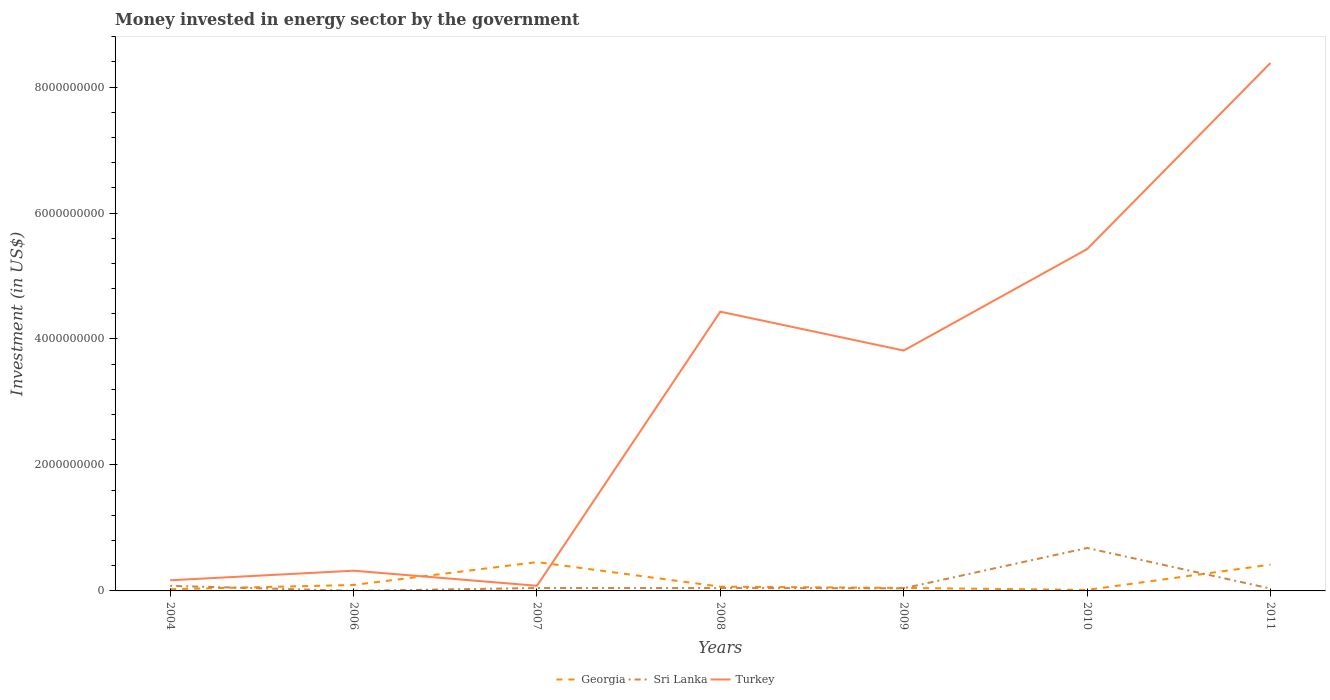Does the line corresponding to Sri Lanka intersect with the line corresponding to Turkey?
Offer a terse response. No. In which year was the money spent in energy sector in Sri Lanka maximum?
Ensure brevity in your answer.  2006. What is the total money spent in energy sector in Turkey in the graph?
Provide a succinct answer. -8.06e+09. What is the difference between the highest and the second highest money spent in energy sector in Turkey?
Offer a very short reply. 8.30e+09. What is the difference between the highest and the lowest money spent in energy sector in Turkey?
Your answer should be compact. 4. Is the money spent in energy sector in Turkey strictly greater than the money spent in energy sector in Sri Lanka over the years?
Your answer should be compact. No. How many lines are there?
Your answer should be very brief. 3. Does the graph contain any zero values?
Your response must be concise. No. Where does the legend appear in the graph?
Keep it short and to the point. Bottom center. How are the legend labels stacked?
Provide a short and direct response. Horizontal. What is the title of the graph?
Offer a very short reply. Money invested in energy sector by the government. What is the label or title of the X-axis?
Make the answer very short. Years. What is the label or title of the Y-axis?
Offer a very short reply. Investment (in US$). What is the Investment (in US$) of Georgia in 2004?
Offer a terse response. 2.70e+07. What is the Investment (in US$) in Sri Lanka in 2004?
Your response must be concise. 8.08e+07. What is the Investment (in US$) of Turkey in 2004?
Your answer should be compact. 1.69e+08. What is the Investment (in US$) of Georgia in 2006?
Ensure brevity in your answer.  9.45e+07. What is the Investment (in US$) of Turkey in 2006?
Offer a terse response. 3.21e+08. What is the Investment (in US$) of Georgia in 2007?
Offer a very short reply. 4.58e+08. What is the Investment (in US$) in Sri Lanka in 2007?
Your answer should be very brief. 4.60e+07. What is the Investment (in US$) of Turkey in 2007?
Offer a very short reply. 8.16e+07. What is the Investment (in US$) in Georgia in 2008?
Make the answer very short. 6.78e+07. What is the Investment (in US$) in Sri Lanka in 2008?
Provide a succinct answer. 4.56e+07. What is the Investment (in US$) in Turkey in 2008?
Provide a succinct answer. 4.43e+09. What is the Investment (in US$) of Georgia in 2009?
Ensure brevity in your answer.  4.77e+07. What is the Investment (in US$) in Sri Lanka in 2009?
Ensure brevity in your answer.  4.17e+07. What is the Investment (in US$) in Turkey in 2009?
Offer a terse response. 3.82e+09. What is the Investment (in US$) in Georgia in 2010?
Give a very brief answer. 1.57e+07. What is the Investment (in US$) of Sri Lanka in 2010?
Ensure brevity in your answer.  6.82e+08. What is the Investment (in US$) in Turkey in 2010?
Offer a terse response. 5.43e+09. What is the Investment (in US$) in Georgia in 2011?
Provide a short and direct response. 4.17e+08. What is the Investment (in US$) of Sri Lanka in 2011?
Offer a terse response. 3.74e+07. What is the Investment (in US$) of Turkey in 2011?
Offer a very short reply. 8.38e+09. Across all years, what is the maximum Investment (in US$) in Georgia?
Provide a short and direct response. 4.58e+08. Across all years, what is the maximum Investment (in US$) of Sri Lanka?
Make the answer very short. 6.82e+08. Across all years, what is the maximum Investment (in US$) in Turkey?
Give a very brief answer. 8.38e+09. Across all years, what is the minimum Investment (in US$) of Georgia?
Give a very brief answer. 1.57e+07. Across all years, what is the minimum Investment (in US$) of Sri Lanka?
Your response must be concise. 1.00e+06. Across all years, what is the minimum Investment (in US$) of Turkey?
Provide a short and direct response. 8.16e+07. What is the total Investment (in US$) of Georgia in the graph?
Your answer should be compact. 1.13e+09. What is the total Investment (in US$) of Sri Lanka in the graph?
Your response must be concise. 9.34e+08. What is the total Investment (in US$) in Turkey in the graph?
Provide a succinct answer. 2.26e+1. What is the difference between the Investment (in US$) of Georgia in 2004 and that in 2006?
Keep it short and to the point. -6.75e+07. What is the difference between the Investment (in US$) in Sri Lanka in 2004 and that in 2006?
Offer a very short reply. 7.98e+07. What is the difference between the Investment (in US$) of Turkey in 2004 and that in 2006?
Ensure brevity in your answer.  -1.52e+08. What is the difference between the Investment (in US$) of Georgia in 2004 and that in 2007?
Ensure brevity in your answer.  -4.31e+08. What is the difference between the Investment (in US$) of Sri Lanka in 2004 and that in 2007?
Provide a succinct answer. 3.48e+07. What is the difference between the Investment (in US$) of Turkey in 2004 and that in 2007?
Provide a short and direct response. 8.74e+07. What is the difference between the Investment (in US$) in Georgia in 2004 and that in 2008?
Your answer should be compact. -4.08e+07. What is the difference between the Investment (in US$) in Sri Lanka in 2004 and that in 2008?
Your answer should be compact. 3.52e+07. What is the difference between the Investment (in US$) in Turkey in 2004 and that in 2008?
Provide a short and direct response. -4.26e+09. What is the difference between the Investment (in US$) in Georgia in 2004 and that in 2009?
Provide a succinct answer. -2.07e+07. What is the difference between the Investment (in US$) in Sri Lanka in 2004 and that in 2009?
Make the answer very short. 3.91e+07. What is the difference between the Investment (in US$) in Turkey in 2004 and that in 2009?
Make the answer very short. -3.65e+09. What is the difference between the Investment (in US$) of Georgia in 2004 and that in 2010?
Offer a terse response. 1.13e+07. What is the difference between the Investment (in US$) of Sri Lanka in 2004 and that in 2010?
Give a very brief answer. -6.01e+08. What is the difference between the Investment (in US$) of Turkey in 2004 and that in 2010?
Offer a terse response. -5.26e+09. What is the difference between the Investment (in US$) in Georgia in 2004 and that in 2011?
Your answer should be very brief. -3.90e+08. What is the difference between the Investment (in US$) in Sri Lanka in 2004 and that in 2011?
Make the answer very short. 4.34e+07. What is the difference between the Investment (in US$) of Turkey in 2004 and that in 2011?
Your answer should be compact. -8.21e+09. What is the difference between the Investment (in US$) in Georgia in 2006 and that in 2007?
Your answer should be compact. -3.63e+08. What is the difference between the Investment (in US$) in Sri Lanka in 2006 and that in 2007?
Provide a succinct answer. -4.50e+07. What is the difference between the Investment (in US$) in Turkey in 2006 and that in 2007?
Your answer should be compact. 2.39e+08. What is the difference between the Investment (in US$) in Georgia in 2006 and that in 2008?
Provide a short and direct response. 2.67e+07. What is the difference between the Investment (in US$) in Sri Lanka in 2006 and that in 2008?
Provide a succinct answer. -4.46e+07. What is the difference between the Investment (in US$) of Turkey in 2006 and that in 2008?
Offer a terse response. -4.11e+09. What is the difference between the Investment (in US$) of Georgia in 2006 and that in 2009?
Give a very brief answer. 4.68e+07. What is the difference between the Investment (in US$) of Sri Lanka in 2006 and that in 2009?
Provide a succinct answer. -4.07e+07. What is the difference between the Investment (in US$) of Turkey in 2006 and that in 2009?
Ensure brevity in your answer.  -3.50e+09. What is the difference between the Investment (in US$) of Georgia in 2006 and that in 2010?
Offer a terse response. 7.88e+07. What is the difference between the Investment (in US$) of Sri Lanka in 2006 and that in 2010?
Ensure brevity in your answer.  -6.81e+08. What is the difference between the Investment (in US$) in Turkey in 2006 and that in 2010?
Your response must be concise. -5.11e+09. What is the difference between the Investment (in US$) in Georgia in 2006 and that in 2011?
Keep it short and to the point. -3.22e+08. What is the difference between the Investment (in US$) of Sri Lanka in 2006 and that in 2011?
Provide a succinct answer. -3.64e+07. What is the difference between the Investment (in US$) in Turkey in 2006 and that in 2011?
Keep it short and to the point. -8.06e+09. What is the difference between the Investment (in US$) in Georgia in 2007 and that in 2008?
Make the answer very short. 3.90e+08. What is the difference between the Investment (in US$) of Turkey in 2007 and that in 2008?
Provide a short and direct response. -4.35e+09. What is the difference between the Investment (in US$) in Georgia in 2007 and that in 2009?
Give a very brief answer. 4.10e+08. What is the difference between the Investment (in US$) of Sri Lanka in 2007 and that in 2009?
Give a very brief answer. 4.30e+06. What is the difference between the Investment (in US$) in Turkey in 2007 and that in 2009?
Give a very brief answer. -3.73e+09. What is the difference between the Investment (in US$) in Georgia in 2007 and that in 2010?
Provide a succinct answer. 4.42e+08. What is the difference between the Investment (in US$) in Sri Lanka in 2007 and that in 2010?
Provide a short and direct response. -6.36e+08. What is the difference between the Investment (in US$) in Turkey in 2007 and that in 2010?
Make the answer very short. -5.35e+09. What is the difference between the Investment (in US$) in Georgia in 2007 and that in 2011?
Offer a terse response. 4.07e+07. What is the difference between the Investment (in US$) in Sri Lanka in 2007 and that in 2011?
Your answer should be compact. 8.60e+06. What is the difference between the Investment (in US$) of Turkey in 2007 and that in 2011?
Offer a very short reply. -8.30e+09. What is the difference between the Investment (in US$) in Georgia in 2008 and that in 2009?
Your answer should be very brief. 2.01e+07. What is the difference between the Investment (in US$) of Sri Lanka in 2008 and that in 2009?
Your answer should be very brief. 3.95e+06. What is the difference between the Investment (in US$) in Turkey in 2008 and that in 2009?
Your response must be concise. 6.18e+08. What is the difference between the Investment (in US$) of Georgia in 2008 and that in 2010?
Your response must be concise. 5.21e+07. What is the difference between the Investment (in US$) in Sri Lanka in 2008 and that in 2010?
Your answer should be compact. -6.36e+08. What is the difference between the Investment (in US$) of Turkey in 2008 and that in 2010?
Offer a terse response. -9.93e+08. What is the difference between the Investment (in US$) of Georgia in 2008 and that in 2011?
Give a very brief answer. -3.49e+08. What is the difference between the Investment (in US$) of Sri Lanka in 2008 and that in 2011?
Your response must be concise. 8.25e+06. What is the difference between the Investment (in US$) of Turkey in 2008 and that in 2011?
Give a very brief answer. -3.95e+09. What is the difference between the Investment (in US$) in Georgia in 2009 and that in 2010?
Offer a terse response. 3.20e+07. What is the difference between the Investment (in US$) of Sri Lanka in 2009 and that in 2010?
Offer a terse response. -6.40e+08. What is the difference between the Investment (in US$) in Turkey in 2009 and that in 2010?
Give a very brief answer. -1.61e+09. What is the difference between the Investment (in US$) of Georgia in 2009 and that in 2011?
Your answer should be very brief. -3.69e+08. What is the difference between the Investment (in US$) in Sri Lanka in 2009 and that in 2011?
Your response must be concise. 4.30e+06. What is the difference between the Investment (in US$) in Turkey in 2009 and that in 2011?
Your answer should be very brief. -4.57e+09. What is the difference between the Investment (in US$) in Georgia in 2010 and that in 2011?
Give a very brief answer. -4.01e+08. What is the difference between the Investment (in US$) of Sri Lanka in 2010 and that in 2011?
Your response must be concise. 6.44e+08. What is the difference between the Investment (in US$) in Turkey in 2010 and that in 2011?
Offer a terse response. -2.96e+09. What is the difference between the Investment (in US$) of Georgia in 2004 and the Investment (in US$) of Sri Lanka in 2006?
Your answer should be very brief. 2.60e+07. What is the difference between the Investment (in US$) of Georgia in 2004 and the Investment (in US$) of Turkey in 2006?
Ensure brevity in your answer.  -2.94e+08. What is the difference between the Investment (in US$) in Sri Lanka in 2004 and the Investment (in US$) in Turkey in 2006?
Provide a short and direct response. -2.40e+08. What is the difference between the Investment (in US$) in Georgia in 2004 and the Investment (in US$) in Sri Lanka in 2007?
Your answer should be very brief. -1.90e+07. What is the difference between the Investment (in US$) of Georgia in 2004 and the Investment (in US$) of Turkey in 2007?
Ensure brevity in your answer.  -5.46e+07. What is the difference between the Investment (in US$) in Sri Lanka in 2004 and the Investment (in US$) in Turkey in 2007?
Ensure brevity in your answer.  -8.00e+05. What is the difference between the Investment (in US$) of Georgia in 2004 and the Investment (in US$) of Sri Lanka in 2008?
Offer a very short reply. -1.86e+07. What is the difference between the Investment (in US$) in Georgia in 2004 and the Investment (in US$) in Turkey in 2008?
Offer a terse response. -4.41e+09. What is the difference between the Investment (in US$) of Sri Lanka in 2004 and the Investment (in US$) of Turkey in 2008?
Offer a terse response. -4.35e+09. What is the difference between the Investment (in US$) in Georgia in 2004 and the Investment (in US$) in Sri Lanka in 2009?
Keep it short and to the point. -1.47e+07. What is the difference between the Investment (in US$) in Georgia in 2004 and the Investment (in US$) in Turkey in 2009?
Provide a succinct answer. -3.79e+09. What is the difference between the Investment (in US$) of Sri Lanka in 2004 and the Investment (in US$) of Turkey in 2009?
Keep it short and to the point. -3.74e+09. What is the difference between the Investment (in US$) of Georgia in 2004 and the Investment (in US$) of Sri Lanka in 2010?
Provide a succinct answer. -6.55e+08. What is the difference between the Investment (in US$) of Georgia in 2004 and the Investment (in US$) of Turkey in 2010?
Make the answer very short. -5.40e+09. What is the difference between the Investment (in US$) of Sri Lanka in 2004 and the Investment (in US$) of Turkey in 2010?
Your answer should be compact. -5.35e+09. What is the difference between the Investment (in US$) in Georgia in 2004 and the Investment (in US$) in Sri Lanka in 2011?
Offer a very short reply. -1.04e+07. What is the difference between the Investment (in US$) in Georgia in 2004 and the Investment (in US$) in Turkey in 2011?
Provide a succinct answer. -8.36e+09. What is the difference between the Investment (in US$) in Sri Lanka in 2004 and the Investment (in US$) in Turkey in 2011?
Provide a succinct answer. -8.30e+09. What is the difference between the Investment (in US$) of Georgia in 2006 and the Investment (in US$) of Sri Lanka in 2007?
Keep it short and to the point. 4.85e+07. What is the difference between the Investment (in US$) in Georgia in 2006 and the Investment (in US$) in Turkey in 2007?
Provide a short and direct response. 1.29e+07. What is the difference between the Investment (in US$) in Sri Lanka in 2006 and the Investment (in US$) in Turkey in 2007?
Your answer should be compact. -8.06e+07. What is the difference between the Investment (in US$) of Georgia in 2006 and the Investment (in US$) of Sri Lanka in 2008?
Ensure brevity in your answer.  4.88e+07. What is the difference between the Investment (in US$) in Georgia in 2006 and the Investment (in US$) in Turkey in 2008?
Give a very brief answer. -4.34e+09. What is the difference between the Investment (in US$) of Sri Lanka in 2006 and the Investment (in US$) of Turkey in 2008?
Your answer should be compact. -4.43e+09. What is the difference between the Investment (in US$) of Georgia in 2006 and the Investment (in US$) of Sri Lanka in 2009?
Offer a very short reply. 5.28e+07. What is the difference between the Investment (in US$) of Georgia in 2006 and the Investment (in US$) of Turkey in 2009?
Provide a succinct answer. -3.72e+09. What is the difference between the Investment (in US$) of Sri Lanka in 2006 and the Investment (in US$) of Turkey in 2009?
Provide a succinct answer. -3.82e+09. What is the difference between the Investment (in US$) of Georgia in 2006 and the Investment (in US$) of Sri Lanka in 2010?
Your response must be concise. -5.87e+08. What is the difference between the Investment (in US$) of Georgia in 2006 and the Investment (in US$) of Turkey in 2010?
Provide a short and direct response. -5.33e+09. What is the difference between the Investment (in US$) in Sri Lanka in 2006 and the Investment (in US$) in Turkey in 2010?
Your answer should be compact. -5.43e+09. What is the difference between the Investment (in US$) of Georgia in 2006 and the Investment (in US$) of Sri Lanka in 2011?
Keep it short and to the point. 5.71e+07. What is the difference between the Investment (in US$) in Georgia in 2006 and the Investment (in US$) in Turkey in 2011?
Ensure brevity in your answer.  -8.29e+09. What is the difference between the Investment (in US$) in Sri Lanka in 2006 and the Investment (in US$) in Turkey in 2011?
Keep it short and to the point. -8.38e+09. What is the difference between the Investment (in US$) of Georgia in 2007 and the Investment (in US$) of Sri Lanka in 2008?
Provide a succinct answer. 4.12e+08. What is the difference between the Investment (in US$) of Georgia in 2007 and the Investment (in US$) of Turkey in 2008?
Make the answer very short. -3.98e+09. What is the difference between the Investment (in US$) of Sri Lanka in 2007 and the Investment (in US$) of Turkey in 2008?
Offer a very short reply. -4.39e+09. What is the difference between the Investment (in US$) of Georgia in 2007 and the Investment (in US$) of Sri Lanka in 2009?
Your answer should be compact. 4.16e+08. What is the difference between the Investment (in US$) in Georgia in 2007 and the Investment (in US$) in Turkey in 2009?
Provide a succinct answer. -3.36e+09. What is the difference between the Investment (in US$) in Sri Lanka in 2007 and the Investment (in US$) in Turkey in 2009?
Your answer should be compact. -3.77e+09. What is the difference between the Investment (in US$) in Georgia in 2007 and the Investment (in US$) in Sri Lanka in 2010?
Make the answer very short. -2.24e+08. What is the difference between the Investment (in US$) in Georgia in 2007 and the Investment (in US$) in Turkey in 2010?
Provide a short and direct response. -4.97e+09. What is the difference between the Investment (in US$) of Sri Lanka in 2007 and the Investment (in US$) of Turkey in 2010?
Ensure brevity in your answer.  -5.38e+09. What is the difference between the Investment (in US$) of Georgia in 2007 and the Investment (in US$) of Sri Lanka in 2011?
Give a very brief answer. 4.20e+08. What is the difference between the Investment (in US$) in Georgia in 2007 and the Investment (in US$) in Turkey in 2011?
Give a very brief answer. -7.92e+09. What is the difference between the Investment (in US$) of Sri Lanka in 2007 and the Investment (in US$) of Turkey in 2011?
Your response must be concise. -8.34e+09. What is the difference between the Investment (in US$) of Georgia in 2008 and the Investment (in US$) of Sri Lanka in 2009?
Offer a terse response. 2.61e+07. What is the difference between the Investment (in US$) of Georgia in 2008 and the Investment (in US$) of Turkey in 2009?
Offer a very short reply. -3.75e+09. What is the difference between the Investment (in US$) in Sri Lanka in 2008 and the Investment (in US$) in Turkey in 2009?
Make the answer very short. -3.77e+09. What is the difference between the Investment (in US$) in Georgia in 2008 and the Investment (in US$) in Sri Lanka in 2010?
Your answer should be very brief. -6.14e+08. What is the difference between the Investment (in US$) of Georgia in 2008 and the Investment (in US$) of Turkey in 2010?
Offer a very short reply. -5.36e+09. What is the difference between the Investment (in US$) of Sri Lanka in 2008 and the Investment (in US$) of Turkey in 2010?
Your answer should be compact. -5.38e+09. What is the difference between the Investment (in US$) of Georgia in 2008 and the Investment (in US$) of Sri Lanka in 2011?
Your answer should be very brief. 3.04e+07. What is the difference between the Investment (in US$) of Georgia in 2008 and the Investment (in US$) of Turkey in 2011?
Your response must be concise. -8.31e+09. What is the difference between the Investment (in US$) of Sri Lanka in 2008 and the Investment (in US$) of Turkey in 2011?
Your answer should be very brief. -8.34e+09. What is the difference between the Investment (in US$) in Georgia in 2009 and the Investment (in US$) in Sri Lanka in 2010?
Provide a succinct answer. -6.34e+08. What is the difference between the Investment (in US$) of Georgia in 2009 and the Investment (in US$) of Turkey in 2010?
Provide a short and direct response. -5.38e+09. What is the difference between the Investment (in US$) of Sri Lanka in 2009 and the Investment (in US$) of Turkey in 2010?
Provide a succinct answer. -5.39e+09. What is the difference between the Investment (in US$) in Georgia in 2009 and the Investment (in US$) in Sri Lanka in 2011?
Offer a terse response. 1.03e+07. What is the difference between the Investment (in US$) in Georgia in 2009 and the Investment (in US$) in Turkey in 2011?
Provide a succinct answer. -8.33e+09. What is the difference between the Investment (in US$) of Sri Lanka in 2009 and the Investment (in US$) of Turkey in 2011?
Offer a very short reply. -8.34e+09. What is the difference between the Investment (in US$) in Georgia in 2010 and the Investment (in US$) in Sri Lanka in 2011?
Your answer should be compact. -2.17e+07. What is the difference between the Investment (in US$) in Georgia in 2010 and the Investment (in US$) in Turkey in 2011?
Your answer should be very brief. -8.37e+09. What is the difference between the Investment (in US$) of Sri Lanka in 2010 and the Investment (in US$) of Turkey in 2011?
Give a very brief answer. -7.70e+09. What is the average Investment (in US$) in Georgia per year?
Offer a very short reply. 1.61e+08. What is the average Investment (in US$) of Sri Lanka per year?
Offer a terse response. 1.33e+08. What is the average Investment (in US$) of Turkey per year?
Ensure brevity in your answer.  3.23e+09. In the year 2004, what is the difference between the Investment (in US$) of Georgia and Investment (in US$) of Sri Lanka?
Your response must be concise. -5.38e+07. In the year 2004, what is the difference between the Investment (in US$) of Georgia and Investment (in US$) of Turkey?
Your answer should be compact. -1.42e+08. In the year 2004, what is the difference between the Investment (in US$) of Sri Lanka and Investment (in US$) of Turkey?
Your answer should be compact. -8.82e+07. In the year 2006, what is the difference between the Investment (in US$) in Georgia and Investment (in US$) in Sri Lanka?
Keep it short and to the point. 9.35e+07. In the year 2006, what is the difference between the Investment (in US$) in Georgia and Investment (in US$) in Turkey?
Give a very brief answer. -2.27e+08. In the year 2006, what is the difference between the Investment (in US$) in Sri Lanka and Investment (in US$) in Turkey?
Provide a short and direct response. -3.20e+08. In the year 2007, what is the difference between the Investment (in US$) in Georgia and Investment (in US$) in Sri Lanka?
Your response must be concise. 4.12e+08. In the year 2007, what is the difference between the Investment (in US$) of Georgia and Investment (in US$) of Turkey?
Offer a very short reply. 3.76e+08. In the year 2007, what is the difference between the Investment (in US$) in Sri Lanka and Investment (in US$) in Turkey?
Your answer should be compact. -3.56e+07. In the year 2008, what is the difference between the Investment (in US$) in Georgia and Investment (in US$) in Sri Lanka?
Your answer should be very brief. 2.22e+07. In the year 2008, what is the difference between the Investment (in US$) in Georgia and Investment (in US$) in Turkey?
Make the answer very short. -4.37e+09. In the year 2008, what is the difference between the Investment (in US$) in Sri Lanka and Investment (in US$) in Turkey?
Your answer should be very brief. -4.39e+09. In the year 2009, what is the difference between the Investment (in US$) in Georgia and Investment (in US$) in Turkey?
Your answer should be compact. -3.77e+09. In the year 2009, what is the difference between the Investment (in US$) in Sri Lanka and Investment (in US$) in Turkey?
Provide a succinct answer. -3.77e+09. In the year 2010, what is the difference between the Investment (in US$) of Georgia and Investment (in US$) of Sri Lanka?
Make the answer very short. -6.66e+08. In the year 2010, what is the difference between the Investment (in US$) in Georgia and Investment (in US$) in Turkey?
Offer a very short reply. -5.41e+09. In the year 2010, what is the difference between the Investment (in US$) in Sri Lanka and Investment (in US$) in Turkey?
Offer a very short reply. -4.75e+09. In the year 2011, what is the difference between the Investment (in US$) of Georgia and Investment (in US$) of Sri Lanka?
Give a very brief answer. 3.80e+08. In the year 2011, what is the difference between the Investment (in US$) in Georgia and Investment (in US$) in Turkey?
Provide a succinct answer. -7.97e+09. In the year 2011, what is the difference between the Investment (in US$) in Sri Lanka and Investment (in US$) in Turkey?
Give a very brief answer. -8.35e+09. What is the ratio of the Investment (in US$) of Georgia in 2004 to that in 2006?
Keep it short and to the point. 0.29. What is the ratio of the Investment (in US$) of Sri Lanka in 2004 to that in 2006?
Ensure brevity in your answer.  80.8. What is the ratio of the Investment (in US$) in Turkey in 2004 to that in 2006?
Keep it short and to the point. 0.53. What is the ratio of the Investment (in US$) in Georgia in 2004 to that in 2007?
Your response must be concise. 0.06. What is the ratio of the Investment (in US$) in Sri Lanka in 2004 to that in 2007?
Your answer should be very brief. 1.76. What is the ratio of the Investment (in US$) of Turkey in 2004 to that in 2007?
Your answer should be very brief. 2.07. What is the ratio of the Investment (in US$) of Georgia in 2004 to that in 2008?
Make the answer very short. 0.4. What is the ratio of the Investment (in US$) of Sri Lanka in 2004 to that in 2008?
Ensure brevity in your answer.  1.77. What is the ratio of the Investment (in US$) in Turkey in 2004 to that in 2008?
Make the answer very short. 0.04. What is the ratio of the Investment (in US$) of Georgia in 2004 to that in 2009?
Make the answer very short. 0.57. What is the ratio of the Investment (in US$) in Sri Lanka in 2004 to that in 2009?
Offer a very short reply. 1.94. What is the ratio of the Investment (in US$) of Turkey in 2004 to that in 2009?
Give a very brief answer. 0.04. What is the ratio of the Investment (in US$) in Georgia in 2004 to that in 2010?
Offer a very short reply. 1.72. What is the ratio of the Investment (in US$) of Sri Lanka in 2004 to that in 2010?
Your answer should be very brief. 0.12. What is the ratio of the Investment (in US$) in Turkey in 2004 to that in 2010?
Keep it short and to the point. 0.03. What is the ratio of the Investment (in US$) of Georgia in 2004 to that in 2011?
Provide a short and direct response. 0.06. What is the ratio of the Investment (in US$) in Sri Lanka in 2004 to that in 2011?
Provide a succinct answer. 2.16. What is the ratio of the Investment (in US$) of Turkey in 2004 to that in 2011?
Ensure brevity in your answer.  0.02. What is the ratio of the Investment (in US$) in Georgia in 2006 to that in 2007?
Offer a very short reply. 0.21. What is the ratio of the Investment (in US$) of Sri Lanka in 2006 to that in 2007?
Offer a very short reply. 0.02. What is the ratio of the Investment (in US$) of Turkey in 2006 to that in 2007?
Keep it short and to the point. 3.93. What is the ratio of the Investment (in US$) in Georgia in 2006 to that in 2008?
Your response must be concise. 1.39. What is the ratio of the Investment (in US$) of Sri Lanka in 2006 to that in 2008?
Give a very brief answer. 0.02. What is the ratio of the Investment (in US$) in Turkey in 2006 to that in 2008?
Offer a terse response. 0.07. What is the ratio of the Investment (in US$) in Georgia in 2006 to that in 2009?
Offer a terse response. 1.98. What is the ratio of the Investment (in US$) in Sri Lanka in 2006 to that in 2009?
Offer a terse response. 0.02. What is the ratio of the Investment (in US$) in Turkey in 2006 to that in 2009?
Provide a succinct answer. 0.08. What is the ratio of the Investment (in US$) in Georgia in 2006 to that in 2010?
Offer a very short reply. 6.02. What is the ratio of the Investment (in US$) of Sri Lanka in 2006 to that in 2010?
Offer a very short reply. 0. What is the ratio of the Investment (in US$) of Turkey in 2006 to that in 2010?
Your answer should be compact. 0.06. What is the ratio of the Investment (in US$) in Georgia in 2006 to that in 2011?
Your answer should be compact. 0.23. What is the ratio of the Investment (in US$) of Sri Lanka in 2006 to that in 2011?
Offer a terse response. 0.03. What is the ratio of the Investment (in US$) of Turkey in 2006 to that in 2011?
Offer a terse response. 0.04. What is the ratio of the Investment (in US$) in Georgia in 2007 to that in 2008?
Offer a terse response. 6.75. What is the ratio of the Investment (in US$) in Sri Lanka in 2007 to that in 2008?
Provide a short and direct response. 1.01. What is the ratio of the Investment (in US$) of Turkey in 2007 to that in 2008?
Ensure brevity in your answer.  0.02. What is the ratio of the Investment (in US$) of Georgia in 2007 to that in 2009?
Ensure brevity in your answer.  9.6. What is the ratio of the Investment (in US$) in Sri Lanka in 2007 to that in 2009?
Your response must be concise. 1.1. What is the ratio of the Investment (in US$) in Turkey in 2007 to that in 2009?
Your answer should be very brief. 0.02. What is the ratio of the Investment (in US$) of Georgia in 2007 to that in 2010?
Your answer should be very brief. 29.15. What is the ratio of the Investment (in US$) in Sri Lanka in 2007 to that in 2010?
Offer a terse response. 0.07. What is the ratio of the Investment (in US$) of Turkey in 2007 to that in 2010?
Your answer should be very brief. 0.01. What is the ratio of the Investment (in US$) of Georgia in 2007 to that in 2011?
Keep it short and to the point. 1.1. What is the ratio of the Investment (in US$) of Sri Lanka in 2007 to that in 2011?
Keep it short and to the point. 1.23. What is the ratio of the Investment (in US$) of Turkey in 2007 to that in 2011?
Your answer should be compact. 0.01. What is the ratio of the Investment (in US$) in Georgia in 2008 to that in 2009?
Provide a succinct answer. 1.42. What is the ratio of the Investment (in US$) in Sri Lanka in 2008 to that in 2009?
Your answer should be very brief. 1.09. What is the ratio of the Investment (in US$) of Turkey in 2008 to that in 2009?
Ensure brevity in your answer.  1.16. What is the ratio of the Investment (in US$) in Georgia in 2008 to that in 2010?
Provide a succinct answer. 4.32. What is the ratio of the Investment (in US$) in Sri Lanka in 2008 to that in 2010?
Your response must be concise. 0.07. What is the ratio of the Investment (in US$) in Turkey in 2008 to that in 2010?
Your response must be concise. 0.82. What is the ratio of the Investment (in US$) of Georgia in 2008 to that in 2011?
Give a very brief answer. 0.16. What is the ratio of the Investment (in US$) in Sri Lanka in 2008 to that in 2011?
Your response must be concise. 1.22. What is the ratio of the Investment (in US$) in Turkey in 2008 to that in 2011?
Offer a very short reply. 0.53. What is the ratio of the Investment (in US$) in Georgia in 2009 to that in 2010?
Your response must be concise. 3.04. What is the ratio of the Investment (in US$) of Sri Lanka in 2009 to that in 2010?
Your answer should be very brief. 0.06. What is the ratio of the Investment (in US$) in Turkey in 2009 to that in 2010?
Provide a short and direct response. 0.7. What is the ratio of the Investment (in US$) in Georgia in 2009 to that in 2011?
Give a very brief answer. 0.11. What is the ratio of the Investment (in US$) in Sri Lanka in 2009 to that in 2011?
Give a very brief answer. 1.11. What is the ratio of the Investment (in US$) in Turkey in 2009 to that in 2011?
Keep it short and to the point. 0.46. What is the ratio of the Investment (in US$) in Georgia in 2010 to that in 2011?
Your response must be concise. 0.04. What is the ratio of the Investment (in US$) in Sri Lanka in 2010 to that in 2011?
Offer a very short reply. 18.22. What is the ratio of the Investment (in US$) in Turkey in 2010 to that in 2011?
Offer a terse response. 0.65. What is the difference between the highest and the second highest Investment (in US$) in Georgia?
Your answer should be compact. 4.07e+07. What is the difference between the highest and the second highest Investment (in US$) in Sri Lanka?
Give a very brief answer. 6.01e+08. What is the difference between the highest and the second highest Investment (in US$) in Turkey?
Give a very brief answer. 2.96e+09. What is the difference between the highest and the lowest Investment (in US$) in Georgia?
Provide a short and direct response. 4.42e+08. What is the difference between the highest and the lowest Investment (in US$) of Sri Lanka?
Provide a succinct answer. 6.81e+08. What is the difference between the highest and the lowest Investment (in US$) of Turkey?
Give a very brief answer. 8.30e+09. 